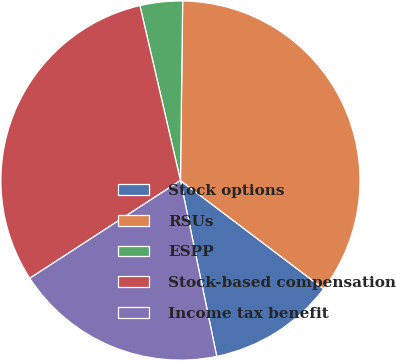<chart> <loc_0><loc_0><loc_500><loc_500><pie_chart><fcel>Stock options<fcel>RSUs<fcel>ESPP<fcel>Stock-based compensation<fcel>Income tax benefit<nl><fcel>11.45%<fcel>35.11%<fcel>3.82%<fcel>30.53%<fcel>19.08%<nl></chart> 